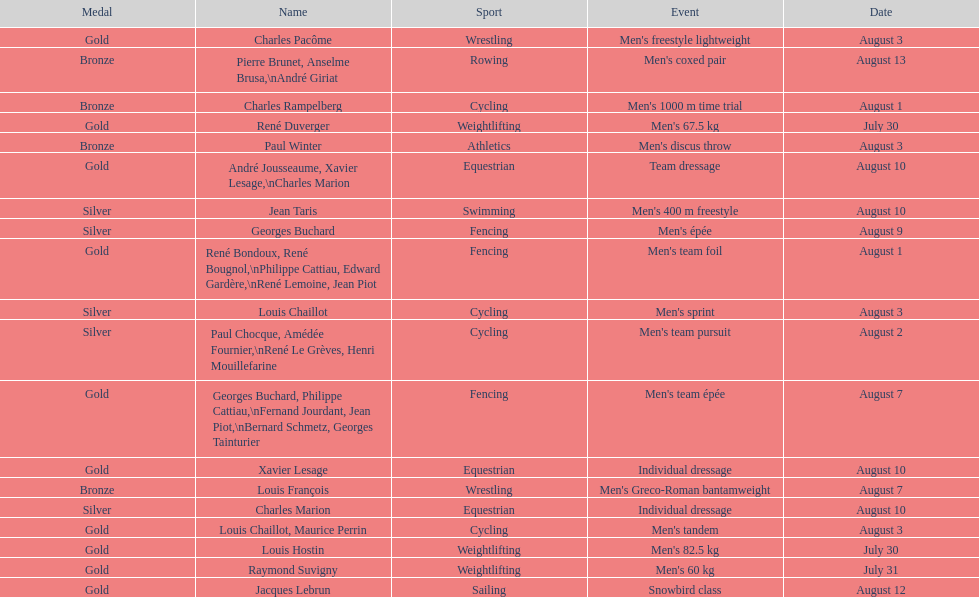What is next date that is listed after august 7th? August 1. 